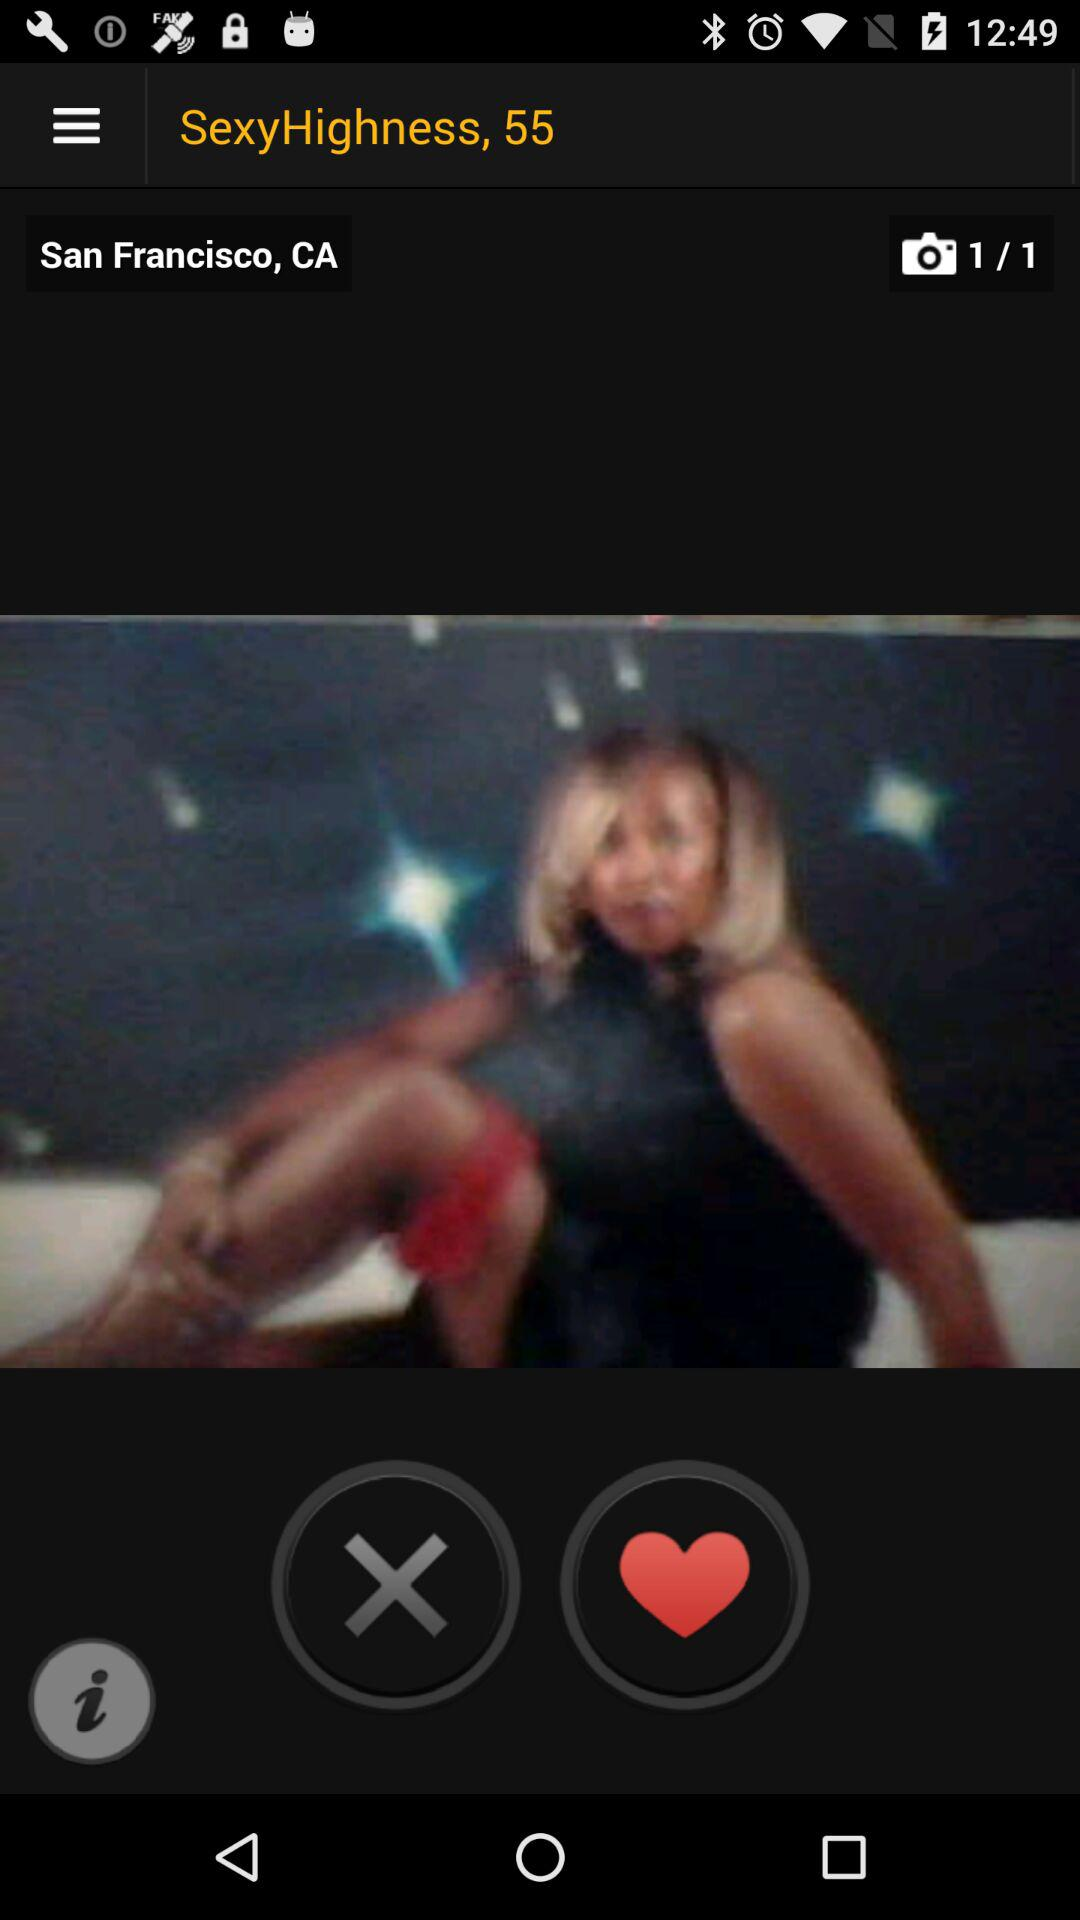How many images are there in total? There is 1 image in total. 